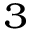Convert formula to latex. <formula><loc_0><loc_0><loc_500><loc_500>_ { 3 }</formula> 